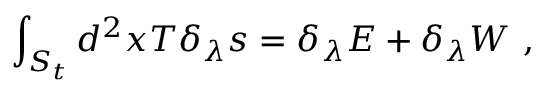<formula> <loc_0><loc_0><loc_500><loc_500>\int _ { S _ { t } } d ^ { 2 } x T \delta _ { \lambda } s = \delta _ { \lambda } E + \delta _ { \lambda } W ,</formula> 